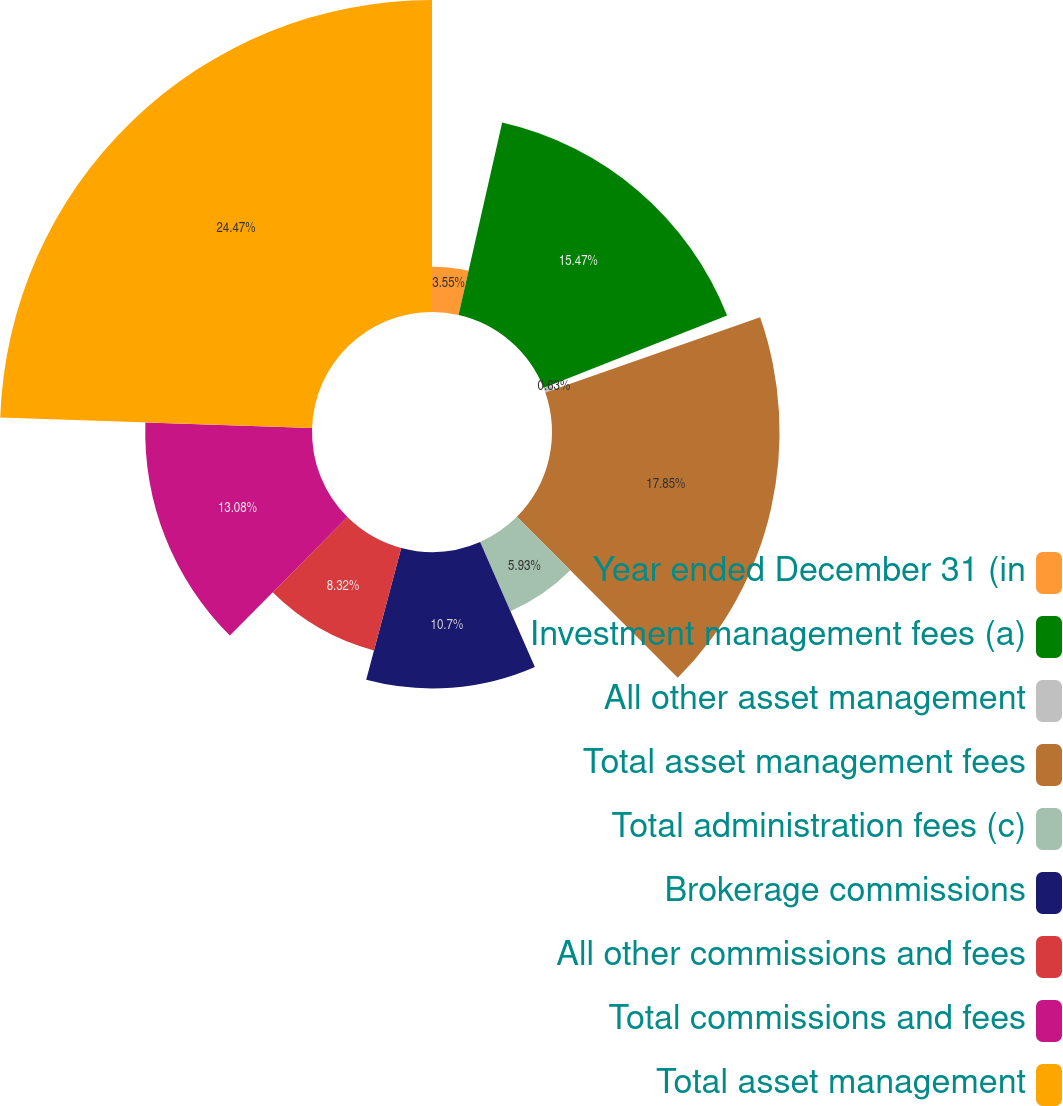Convert chart. <chart><loc_0><loc_0><loc_500><loc_500><pie_chart><fcel>Year ended December 31 (in<fcel>Investment management fees (a)<fcel>All other asset management<fcel>Total asset management fees<fcel>Total administration fees (c)<fcel>Brokerage commissions<fcel>All other commissions and fees<fcel>Total commissions and fees<fcel>Total asset management<nl><fcel>3.55%<fcel>15.47%<fcel>0.63%<fcel>17.85%<fcel>5.93%<fcel>10.7%<fcel>8.32%<fcel>13.08%<fcel>24.47%<nl></chart> 